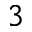Convert formula to latex. <formula><loc_0><loc_0><loc_500><loc_500>^ { 3 }</formula> 